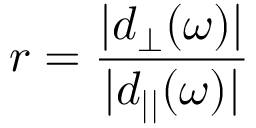Convert formula to latex. <formula><loc_0><loc_0><loc_500><loc_500>r = \frac { | d _ { \perp } ( \omega ) | } { | d _ { | | } ( \omega ) | }</formula> 